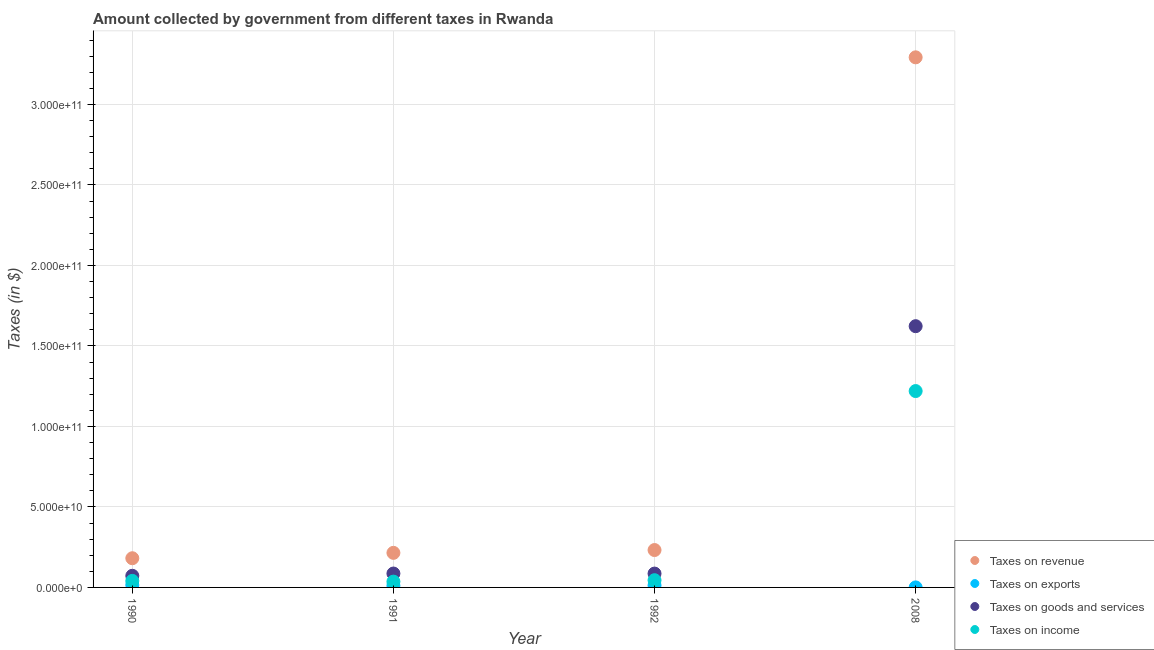How many different coloured dotlines are there?
Ensure brevity in your answer.  4. Is the number of dotlines equal to the number of legend labels?
Provide a short and direct response. Yes. What is the amount collected as tax on exports in 2008?
Offer a terse response. 1.73e+07. Across all years, what is the maximum amount collected as tax on exports?
Offer a terse response. 1.51e+09. Across all years, what is the minimum amount collected as tax on goods?
Ensure brevity in your answer.  7.23e+09. What is the total amount collected as tax on income in the graph?
Your answer should be compact. 1.34e+11. What is the difference between the amount collected as tax on income in 1991 and that in 2008?
Your response must be concise. -1.18e+11. What is the difference between the amount collected as tax on goods in 1990 and the amount collected as tax on exports in 1991?
Ensure brevity in your answer.  6.12e+09. What is the average amount collected as tax on revenue per year?
Your answer should be very brief. 9.80e+1. In the year 1992, what is the difference between the amount collected as tax on goods and amount collected as tax on income?
Offer a terse response. 4.12e+09. What is the ratio of the amount collected as tax on goods in 1991 to that in 2008?
Your answer should be very brief. 0.05. Is the amount collected as tax on income in 1990 less than that in 2008?
Ensure brevity in your answer.  Yes. What is the difference between the highest and the second highest amount collected as tax on income?
Your response must be concise. 1.17e+11. What is the difference between the highest and the lowest amount collected as tax on goods?
Your response must be concise. 1.55e+11. In how many years, is the amount collected as tax on exports greater than the average amount collected as tax on exports taken over all years?
Your response must be concise. 3. Is it the case that in every year, the sum of the amount collected as tax on revenue and amount collected as tax on exports is greater than the amount collected as tax on goods?
Your response must be concise. Yes. Does the amount collected as tax on income monotonically increase over the years?
Offer a very short reply. No. Is the amount collected as tax on income strictly greater than the amount collected as tax on revenue over the years?
Keep it short and to the point. No. Is the amount collected as tax on exports strictly less than the amount collected as tax on goods over the years?
Ensure brevity in your answer.  Yes. How many dotlines are there?
Your response must be concise. 4. How many years are there in the graph?
Make the answer very short. 4. What is the difference between two consecutive major ticks on the Y-axis?
Ensure brevity in your answer.  5.00e+1. Are the values on the major ticks of Y-axis written in scientific E-notation?
Provide a succinct answer. Yes. Where does the legend appear in the graph?
Offer a terse response. Bottom right. How are the legend labels stacked?
Offer a terse response. Vertical. What is the title of the graph?
Make the answer very short. Amount collected by government from different taxes in Rwanda. Does "Other expenses" appear as one of the legend labels in the graph?
Keep it short and to the point. No. What is the label or title of the X-axis?
Keep it short and to the point. Year. What is the label or title of the Y-axis?
Provide a succinct answer. Taxes (in $). What is the Taxes (in $) of Taxes on revenue in 1990?
Offer a terse response. 1.81e+1. What is the Taxes (in $) of Taxes on exports in 1990?
Provide a succinct answer. 1.51e+09. What is the Taxes (in $) in Taxes on goods and services in 1990?
Ensure brevity in your answer.  7.23e+09. What is the Taxes (in $) in Taxes on income in 1990?
Offer a very short reply. 4.06e+09. What is the Taxes (in $) of Taxes on revenue in 1991?
Offer a very short reply. 2.15e+1. What is the Taxes (in $) in Taxes on exports in 1991?
Make the answer very short. 1.11e+09. What is the Taxes (in $) in Taxes on goods and services in 1991?
Keep it short and to the point. 8.63e+09. What is the Taxes (in $) in Taxes on income in 1991?
Your answer should be compact. 3.60e+09. What is the Taxes (in $) of Taxes on revenue in 1992?
Offer a very short reply. 2.32e+1. What is the Taxes (in $) of Taxes on exports in 1992?
Your response must be concise. 1.29e+09. What is the Taxes (in $) of Taxes on goods and services in 1992?
Offer a very short reply. 8.60e+09. What is the Taxes (in $) of Taxes on income in 1992?
Make the answer very short. 4.49e+09. What is the Taxes (in $) of Taxes on revenue in 2008?
Provide a short and direct response. 3.29e+11. What is the Taxes (in $) of Taxes on exports in 2008?
Your answer should be very brief. 1.73e+07. What is the Taxes (in $) of Taxes on goods and services in 2008?
Provide a short and direct response. 1.62e+11. What is the Taxes (in $) in Taxes on income in 2008?
Ensure brevity in your answer.  1.22e+11. Across all years, what is the maximum Taxes (in $) in Taxes on revenue?
Your answer should be compact. 3.29e+11. Across all years, what is the maximum Taxes (in $) of Taxes on exports?
Your answer should be very brief. 1.51e+09. Across all years, what is the maximum Taxes (in $) of Taxes on goods and services?
Provide a short and direct response. 1.62e+11. Across all years, what is the maximum Taxes (in $) of Taxes on income?
Your answer should be compact. 1.22e+11. Across all years, what is the minimum Taxes (in $) of Taxes on revenue?
Your response must be concise. 1.81e+1. Across all years, what is the minimum Taxes (in $) in Taxes on exports?
Offer a very short reply. 1.73e+07. Across all years, what is the minimum Taxes (in $) in Taxes on goods and services?
Give a very brief answer. 7.23e+09. Across all years, what is the minimum Taxes (in $) in Taxes on income?
Your response must be concise. 3.60e+09. What is the total Taxes (in $) of Taxes on revenue in the graph?
Offer a very short reply. 3.92e+11. What is the total Taxes (in $) of Taxes on exports in the graph?
Make the answer very short. 3.92e+09. What is the total Taxes (in $) of Taxes on goods and services in the graph?
Offer a very short reply. 1.87e+11. What is the total Taxes (in $) of Taxes on income in the graph?
Keep it short and to the point. 1.34e+11. What is the difference between the Taxes (in $) in Taxes on revenue in 1990 and that in 1991?
Provide a succinct answer. -3.34e+09. What is the difference between the Taxes (in $) in Taxes on exports in 1990 and that in 1991?
Provide a short and direct response. 3.99e+08. What is the difference between the Taxes (in $) of Taxes on goods and services in 1990 and that in 1991?
Your answer should be compact. -1.40e+09. What is the difference between the Taxes (in $) in Taxes on income in 1990 and that in 1991?
Keep it short and to the point. 4.54e+08. What is the difference between the Taxes (in $) in Taxes on revenue in 1990 and that in 1992?
Make the answer very short. -5.09e+09. What is the difference between the Taxes (in $) in Taxes on exports in 1990 and that in 1992?
Offer a very short reply. 2.14e+08. What is the difference between the Taxes (in $) in Taxes on goods and services in 1990 and that in 1992?
Keep it short and to the point. -1.38e+09. What is the difference between the Taxes (in $) of Taxes on income in 1990 and that in 1992?
Give a very brief answer. -4.31e+08. What is the difference between the Taxes (in $) in Taxes on revenue in 1990 and that in 2008?
Your response must be concise. -3.11e+11. What is the difference between the Taxes (in $) of Taxes on exports in 1990 and that in 2008?
Offer a very short reply. 1.49e+09. What is the difference between the Taxes (in $) of Taxes on goods and services in 1990 and that in 2008?
Provide a succinct answer. -1.55e+11. What is the difference between the Taxes (in $) in Taxes on income in 1990 and that in 2008?
Your response must be concise. -1.18e+11. What is the difference between the Taxes (in $) of Taxes on revenue in 1991 and that in 1992?
Your response must be concise. -1.75e+09. What is the difference between the Taxes (in $) of Taxes on exports in 1991 and that in 1992?
Provide a short and direct response. -1.85e+08. What is the difference between the Taxes (in $) of Taxes on goods and services in 1991 and that in 1992?
Provide a succinct answer. 2.90e+07. What is the difference between the Taxes (in $) of Taxes on income in 1991 and that in 1992?
Ensure brevity in your answer.  -8.85e+08. What is the difference between the Taxes (in $) of Taxes on revenue in 1991 and that in 2008?
Provide a succinct answer. -3.08e+11. What is the difference between the Taxes (in $) of Taxes on exports in 1991 and that in 2008?
Give a very brief answer. 1.09e+09. What is the difference between the Taxes (in $) in Taxes on goods and services in 1991 and that in 2008?
Offer a very short reply. -1.54e+11. What is the difference between the Taxes (in $) in Taxes on income in 1991 and that in 2008?
Keep it short and to the point. -1.18e+11. What is the difference between the Taxes (in $) in Taxes on revenue in 1992 and that in 2008?
Ensure brevity in your answer.  -3.06e+11. What is the difference between the Taxes (in $) of Taxes on exports in 1992 and that in 2008?
Offer a very short reply. 1.27e+09. What is the difference between the Taxes (in $) of Taxes on goods and services in 1992 and that in 2008?
Keep it short and to the point. -1.54e+11. What is the difference between the Taxes (in $) in Taxes on income in 1992 and that in 2008?
Your answer should be very brief. -1.17e+11. What is the difference between the Taxes (in $) in Taxes on revenue in 1990 and the Taxes (in $) in Taxes on exports in 1991?
Provide a succinct answer. 1.70e+1. What is the difference between the Taxes (in $) in Taxes on revenue in 1990 and the Taxes (in $) in Taxes on goods and services in 1991?
Keep it short and to the point. 9.50e+09. What is the difference between the Taxes (in $) of Taxes on revenue in 1990 and the Taxes (in $) of Taxes on income in 1991?
Provide a succinct answer. 1.45e+1. What is the difference between the Taxes (in $) of Taxes on exports in 1990 and the Taxes (in $) of Taxes on goods and services in 1991?
Ensure brevity in your answer.  -7.13e+09. What is the difference between the Taxes (in $) of Taxes on exports in 1990 and the Taxes (in $) of Taxes on income in 1991?
Keep it short and to the point. -2.10e+09. What is the difference between the Taxes (in $) of Taxes on goods and services in 1990 and the Taxes (in $) of Taxes on income in 1991?
Offer a terse response. 3.63e+09. What is the difference between the Taxes (in $) in Taxes on revenue in 1990 and the Taxes (in $) in Taxes on exports in 1992?
Give a very brief answer. 1.68e+1. What is the difference between the Taxes (in $) in Taxes on revenue in 1990 and the Taxes (in $) in Taxes on goods and services in 1992?
Keep it short and to the point. 9.52e+09. What is the difference between the Taxes (in $) of Taxes on revenue in 1990 and the Taxes (in $) of Taxes on income in 1992?
Your answer should be very brief. 1.36e+1. What is the difference between the Taxes (in $) in Taxes on exports in 1990 and the Taxes (in $) in Taxes on goods and services in 1992?
Ensure brevity in your answer.  -7.10e+09. What is the difference between the Taxes (in $) in Taxes on exports in 1990 and the Taxes (in $) in Taxes on income in 1992?
Keep it short and to the point. -2.98e+09. What is the difference between the Taxes (in $) of Taxes on goods and services in 1990 and the Taxes (in $) of Taxes on income in 1992?
Your answer should be very brief. 2.74e+09. What is the difference between the Taxes (in $) of Taxes on revenue in 1990 and the Taxes (in $) of Taxes on exports in 2008?
Offer a very short reply. 1.81e+1. What is the difference between the Taxes (in $) in Taxes on revenue in 1990 and the Taxes (in $) in Taxes on goods and services in 2008?
Provide a succinct answer. -1.44e+11. What is the difference between the Taxes (in $) in Taxes on revenue in 1990 and the Taxes (in $) in Taxes on income in 2008?
Make the answer very short. -1.04e+11. What is the difference between the Taxes (in $) in Taxes on exports in 1990 and the Taxes (in $) in Taxes on goods and services in 2008?
Your answer should be compact. -1.61e+11. What is the difference between the Taxes (in $) of Taxes on exports in 1990 and the Taxes (in $) of Taxes on income in 2008?
Provide a short and direct response. -1.20e+11. What is the difference between the Taxes (in $) of Taxes on goods and services in 1990 and the Taxes (in $) of Taxes on income in 2008?
Make the answer very short. -1.15e+11. What is the difference between the Taxes (in $) of Taxes on revenue in 1991 and the Taxes (in $) of Taxes on exports in 1992?
Give a very brief answer. 2.02e+1. What is the difference between the Taxes (in $) in Taxes on revenue in 1991 and the Taxes (in $) in Taxes on goods and services in 1992?
Offer a terse response. 1.29e+1. What is the difference between the Taxes (in $) of Taxes on revenue in 1991 and the Taxes (in $) of Taxes on income in 1992?
Provide a succinct answer. 1.70e+1. What is the difference between the Taxes (in $) in Taxes on exports in 1991 and the Taxes (in $) in Taxes on goods and services in 1992?
Offer a terse response. -7.50e+09. What is the difference between the Taxes (in $) in Taxes on exports in 1991 and the Taxes (in $) in Taxes on income in 1992?
Give a very brief answer. -3.38e+09. What is the difference between the Taxes (in $) of Taxes on goods and services in 1991 and the Taxes (in $) of Taxes on income in 1992?
Offer a terse response. 4.14e+09. What is the difference between the Taxes (in $) in Taxes on revenue in 1991 and the Taxes (in $) in Taxes on exports in 2008?
Give a very brief answer. 2.15e+1. What is the difference between the Taxes (in $) of Taxes on revenue in 1991 and the Taxes (in $) of Taxes on goods and services in 2008?
Provide a succinct answer. -1.41e+11. What is the difference between the Taxes (in $) of Taxes on revenue in 1991 and the Taxes (in $) of Taxes on income in 2008?
Offer a terse response. -1.00e+11. What is the difference between the Taxes (in $) of Taxes on exports in 1991 and the Taxes (in $) of Taxes on goods and services in 2008?
Your response must be concise. -1.61e+11. What is the difference between the Taxes (in $) of Taxes on exports in 1991 and the Taxes (in $) of Taxes on income in 2008?
Ensure brevity in your answer.  -1.21e+11. What is the difference between the Taxes (in $) of Taxes on goods and services in 1991 and the Taxes (in $) of Taxes on income in 2008?
Your answer should be very brief. -1.13e+11. What is the difference between the Taxes (in $) of Taxes on revenue in 1992 and the Taxes (in $) of Taxes on exports in 2008?
Provide a short and direct response. 2.32e+1. What is the difference between the Taxes (in $) of Taxes on revenue in 1992 and the Taxes (in $) of Taxes on goods and services in 2008?
Provide a short and direct response. -1.39e+11. What is the difference between the Taxes (in $) in Taxes on revenue in 1992 and the Taxes (in $) in Taxes on income in 2008?
Offer a very short reply. -9.87e+1. What is the difference between the Taxes (in $) of Taxes on exports in 1992 and the Taxes (in $) of Taxes on goods and services in 2008?
Your answer should be compact. -1.61e+11. What is the difference between the Taxes (in $) of Taxes on exports in 1992 and the Taxes (in $) of Taxes on income in 2008?
Keep it short and to the point. -1.21e+11. What is the difference between the Taxes (in $) in Taxes on goods and services in 1992 and the Taxes (in $) in Taxes on income in 2008?
Provide a short and direct response. -1.13e+11. What is the average Taxes (in $) of Taxes on revenue per year?
Provide a succinct answer. 9.80e+1. What is the average Taxes (in $) in Taxes on exports per year?
Your response must be concise. 9.81e+08. What is the average Taxes (in $) in Taxes on goods and services per year?
Offer a terse response. 4.67e+1. What is the average Taxes (in $) in Taxes on income per year?
Give a very brief answer. 3.35e+1. In the year 1990, what is the difference between the Taxes (in $) of Taxes on revenue and Taxes (in $) of Taxes on exports?
Ensure brevity in your answer.  1.66e+1. In the year 1990, what is the difference between the Taxes (in $) in Taxes on revenue and Taxes (in $) in Taxes on goods and services?
Provide a short and direct response. 1.09e+1. In the year 1990, what is the difference between the Taxes (in $) in Taxes on revenue and Taxes (in $) in Taxes on income?
Ensure brevity in your answer.  1.41e+1. In the year 1990, what is the difference between the Taxes (in $) in Taxes on exports and Taxes (in $) in Taxes on goods and services?
Give a very brief answer. -5.72e+09. In the year 1990, what is the difference between the Taxes (in $) of Taxes on exports and Taxes (in $) of Taxes on income?
Offer a very short reply. -2.55e+09. In the year 1990, what is the difference between the Taxes (in $) of Taxes on goods and services and Taxes (in $) of Taxes on income?
Keep it short and to the point. 3.17e+09. In the year 1991, what is the difference between the Taxes (in $) in Taxes on revenue and Taxes (in $) in Taxes on exports?
Keep it short and to the point. 2.04e+1. In the year 1991, what is the difference between the Taxes (in $) of Taxes on revenue and Taxes (in $) of Taxes on goods and services?
Give a very brief answer. 1.28e+1. In the year 1991, what is the difference between the Taxes (in $) in Taxes on revenue and Taxes (in $) in Taxes on income?
Your answer should be very brief. 1.79e+1. In the year 1991, what is the difference between the Taxes (in $) of Taxes on exports and Taxes (in $) of Taxes on goods and services?
Give a very brief answer. -7.52e+09. In the year 1991, what is the difference between the Taxes (in $) of Taxes on exports and Taxes (in $) of Taxes on income?
Offer a very short reply. -2.50e+09. In the year 1991, what is the difference between the Taxes (in $) of Taxes on goods and services and Taxes (in $) of Taxes on income?
Provide a short and direct response. 5.03e+09. In the year 1992, what is the difference between the Taxes (in $) in Taxes on revenue and Taxes (in $) in Taxes on exports?
Offer a very short reply. 2.19e+1. In the year 1992, what is the difference between the Taxes (in $) of Taxes on revenue and Taxes (in $) of Taxes on goods and services?
Provide a succinct answer. 1.46e+1. In the year 1992, what is the difference between the Taxes (in $) in Taxes on revenue and Taxes (in $) in Taxes on income?
Ensure brevity in your answer.  1.87e+1. In the year 1992, what is the difference between the Taxes (in $) of Taxes on exports and Taxes (in $) of Taxes on goods and services?
Your response must be concise. -7.31e+09. In the year 1992, what is the difference between the Taxes (in $) of Taxes on exports and Taxes (in $) of Taxes on income?
Provide a succinct answer. -3.20e+09. In the year 1992, what is the difference between the Taxes (in $) of Taxes on goods and services and Taxes (in $) of Taxes on income?
Make the answer very short. 4.12e+09. In the year 2008, what is the difference between the Taxes (in $) of Taxes on revenue and Taxes (in $) of Taxes on exports?
Offer a very short reply. 3.29e+11. In the year 2008, what is the difference between the Taxes (in $) in Taxes on revenue and Taxes (in $) in Taxes on goods and services?
Make the answer very short. 1.67e+11. In the year 2008, what is the difference between the Taxes (in $) of Taxes on revenue and Taxes (in $) of Taxes on income?
Keep it short and to the point. 2.07e+11. In the year 2008, what is the difference between the Taxes (in $) in Taxes on exports and Taxes (in $) in Taxes on goods and services?
Your response must be concise. -1.62e+11. In the year 2008, what is the difference between the Taxes (in $) of Taxes on exports and Taxes (in $) of Taxes on income?
Your answer should be compact. -1.22e+11. In the year 2008, what is the difference between the Taxes (in $) in Taxes on goods and services and Taxes (in $) in Taxes on income?
Give a very brief answer. 4.03e+1. What is the ratio of the Taxes (in $) of Taxes on revenue in 1990 to that in 1991?
Ensure brevity in your answer.  0.84. What is the ratio of the Taxes (in $) in Taxes on exports in 1990 to that in 1991?
Your answer should be compact. 1.36. What is the ratio of the Taxes (in $) in Taxes on goods and services in 1990 to that in 1991?
Offer a very short reply. 0.84. What is the ratio of the Taxes (in $) of Taxes on income in 1990 to that in 1991?
Provide a succinct answer. 1.13. What is the ratio of the Taxes (in $) of Taxes on revenue in 1990 to that in 1992?
Offer a very short reply. 0.78. What is the ratio of the Taxes (in $) of Taxes on exports in 1990 to that in 1992?
Your answer should be very brief. 1.17. What is the ratio of the Taxes (in $) in Taxes on goods and services in 1990 to that in 1992?
Keep it short and to the point. 0.84. What is the ratio of the Taxes (in $) of Taxes on income in 1990 to that in 1992?
Ensure brevity in your answer.  0.9. What is the ratio of the Taxes (in $) in Taxes on revenue in 1990 to that in 2008?
Offer a terse response. 0.06. What is the ratio of the Taxes (in $) of Taxes on exports in 1990 to that in 2008?
Make the answer very short. 87.09. What is the ratio of the Taxes (in $) of Taxes on goods and services in 1990 to that in 2008?
Give a very brief answer. 0.04. What is the ratio of the Taxes (in $) of Taxes on income in 1990 to that in 2008?
Provide a succinct answer. 0.03. What is the ratio of the Taxes (in $) in Taxes on revenue in 1991 to that in 1992?
Give a very brief answer. 0.92. What is the ratio of the Taxes (in $) of Taxes on exports in 1991 to that in 1992?
Ensure brevity in your answer.  0.86. What is the ratio of the Taxes (in $) in Taxes on income in 1991 to that in 1992?
Offer a terse response. 0.8. What is the ratio of the Taxes (in $) in Taxes on revenue in 1991 to that in 2008?
Your answer should be compact. 0.07. What is the ratio of the Taxes (in $) of Taxes on exports in 1991 to that in 2008?
Keep it short and to the point. 64.02. What is the ratio of the Taxes (in $) of Taxes on goods and services in 1991 to that in 2008?
Provide a short and direct response. 0.05. What is the ratio of the Taxes (in $) of Taxes on income in 1991 to that in 2008?
Provide a short and direct response. 0.03. What is the ratio of the Taxes (in $) in Taxes on revenue in 1992 to that in 2008?
Make the answer very short. 0.07. What is the ratio of the Taxes (in $) of Taxes on exports in 1992 to that in 2008?
Offer a very short reply. 74.72. What is the ratio of the Taxes (in $) of Taxes on goods and services in 1992 to that in 2008?
Offer a very short reply. 0.05. What is the ratio of the Taxes (in $) in Taxes on income in 1992 to that in 2008?
Your response must be concise. 0.04. What is the difference between the highest and the second highest Taxes (in $) in Taxes on revenue?
Provide a succinct answer. 3.06e+11. What is the difference between the highest and the second highest Taxes (in $) in Taxes on exports?
Your response must be concise. 2.14e+08. What is the difference between the highest and the second highest Taxes (in $) of Taxes on goods and services?
Keep it short and to the point. 1.54e+11. What is the difference between the highest and the second highest Taxes (in $) in Taxes on income?
Offer a terse response. 1.17e+11. What is the difference between the highest and the lowest Taxes (in $) of Taxes on revenue?
Offer a very short reply. 3.11e+11. What is the difference between the highest and the lowest Taxes (in $) in Taxes on exports?
Your answer should be very brief. 1.49e+09. What is the difference between the highest and the lowest Taxes (in $) in Taxes on goods and services?
Give a very brief answer. 1.55e+11. What is the difference between the highest and the lowest Taxes (in $) in Taxes on income?
Your answer should be very brief. 1.18e+11. 